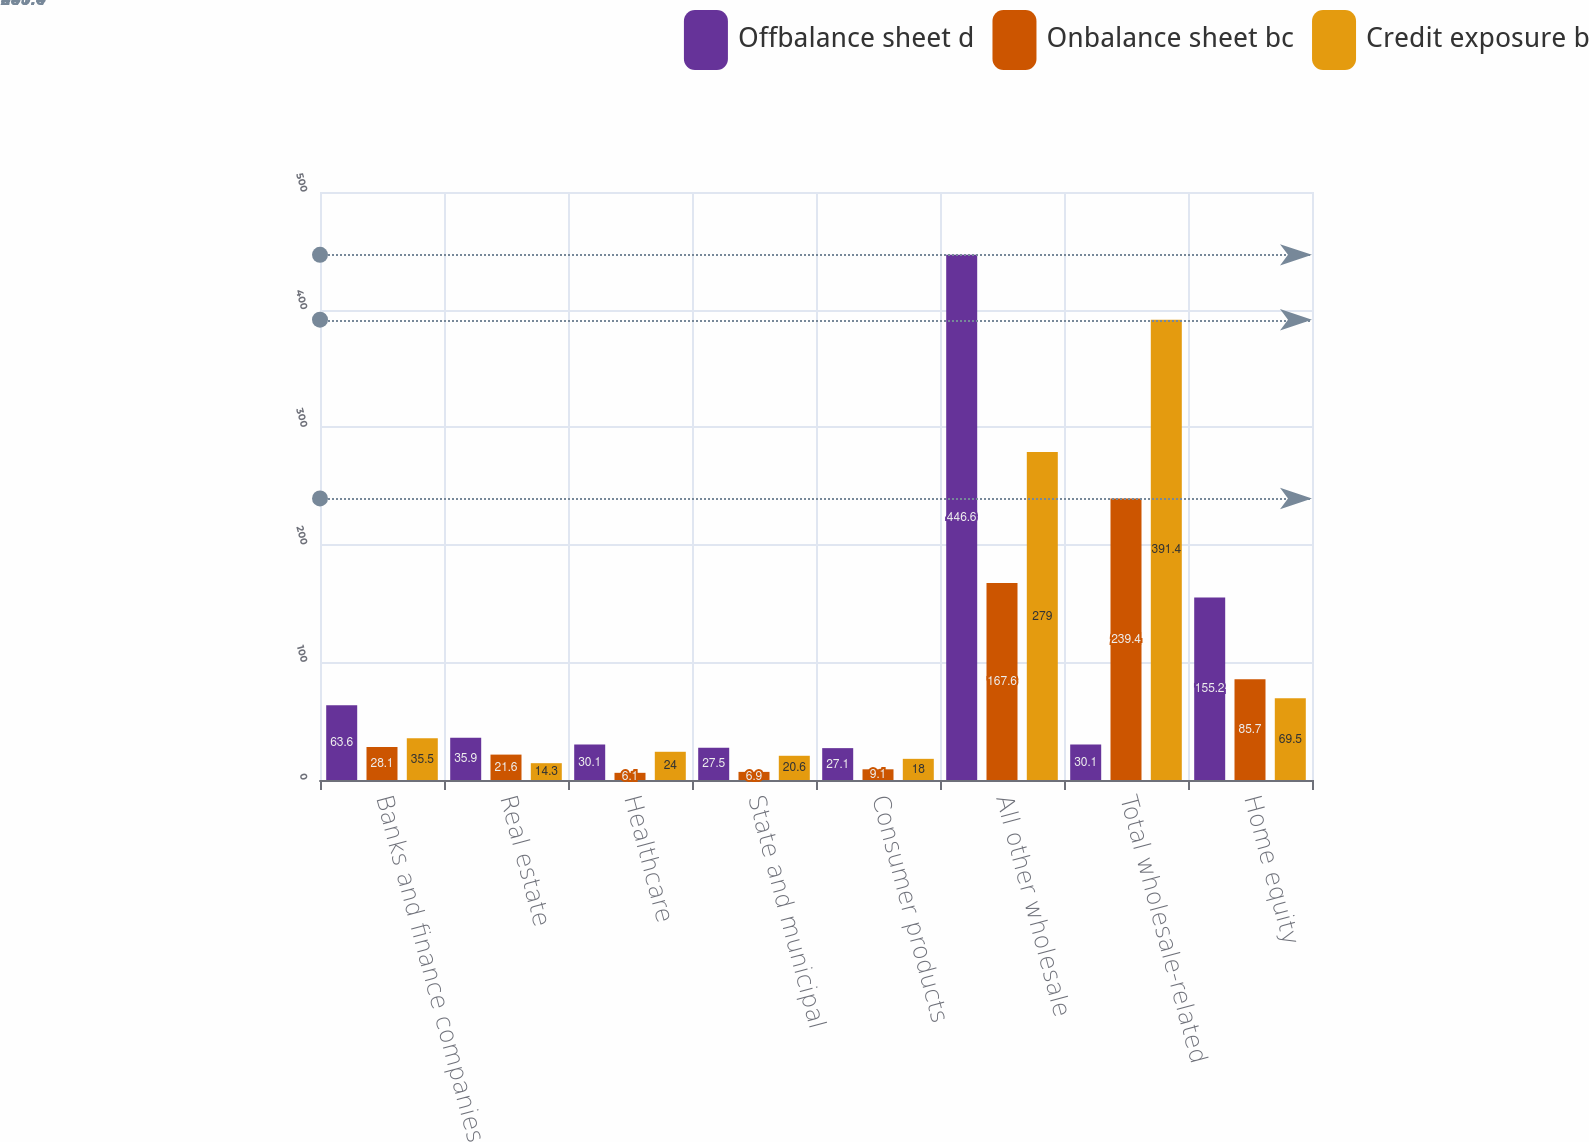Convert chart. <chart><loc_0><loc_0><loc_500><loc_500><stacked_bar_chart><ecel><fcel>Banks and finance companies<fcel>Real estate<fcel>Healthcare<fcel>State and municipal<fcel>Consumer products<fcel>All other wholesale<fcel>Total wholesale-related<fcel>Home equity<nl><fcel>Offbalance sheet d<fcel>63.6<fcel>35.9<fcel>30.1<fcel>27.5<fcel>27.1<fcel>446.6<fcel>30.1<fcel>155.2<nl><fcel>Onbalance sheet bc<fcel>28.1<fcel>21.6<fcel>6.1<fcel>6.9<fcel>9.1<fcel>167.6<fcel>239.4<fcel>85.7<nl><fcel>Credit exposure b<fcel>35.5<fcel>14.3<fcel>24<fcel>20.6<fcel>18<fcel>279<fcel>391.4<fcel>69.5<nl></chart> 